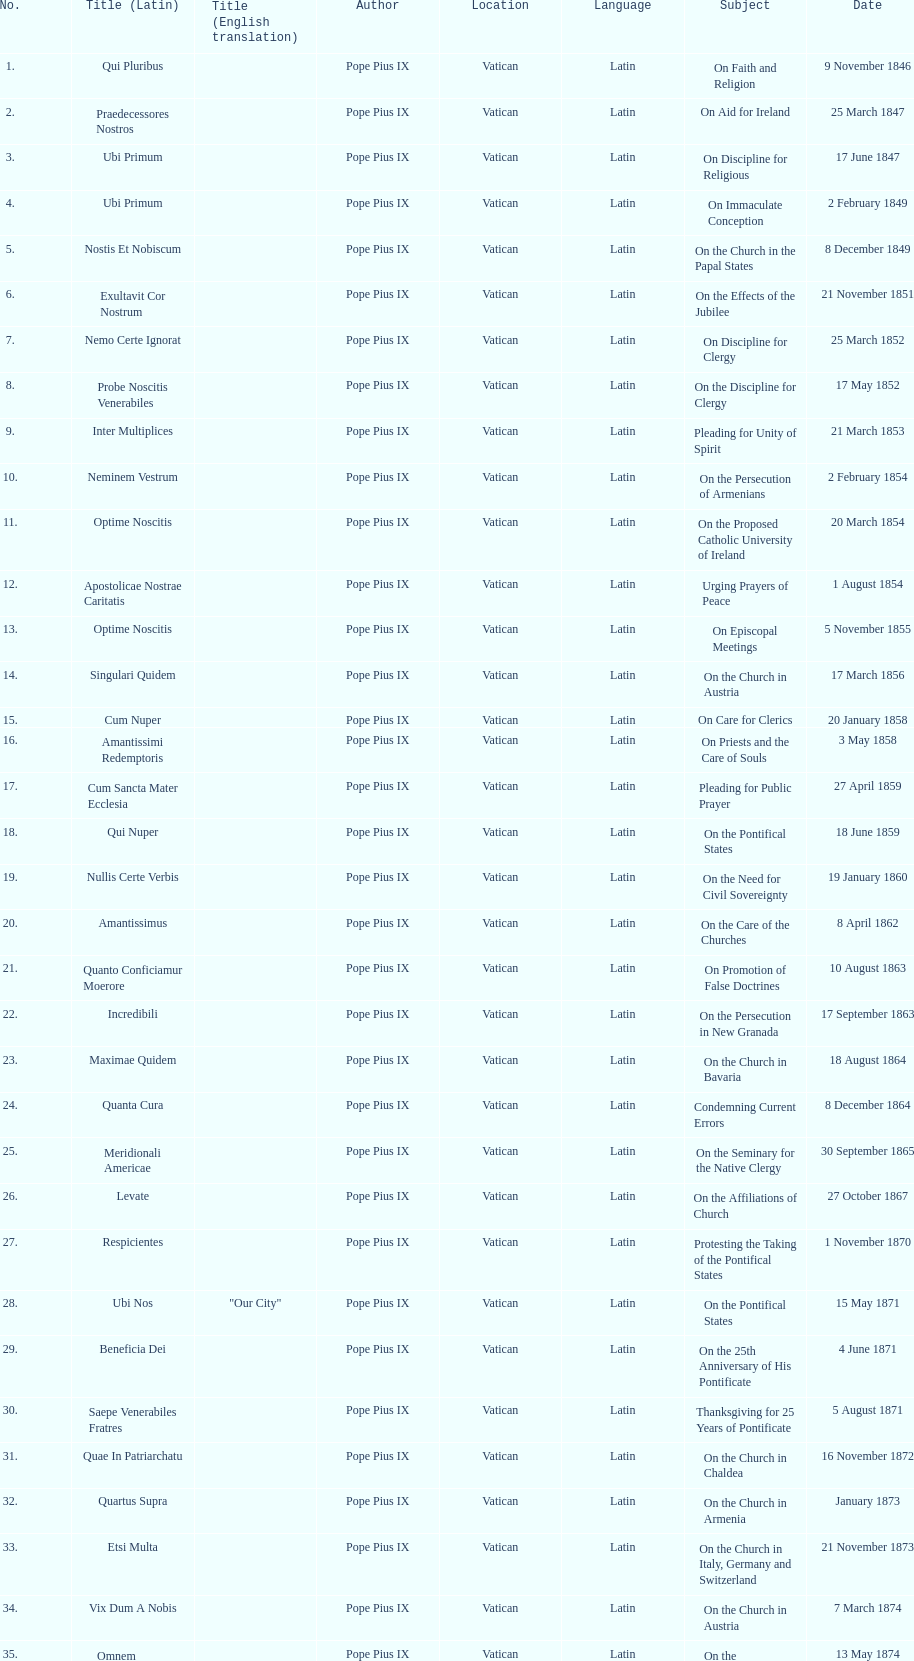Date of the last encyclical whose subject contained the word "pontificate" 5 August 1871. 